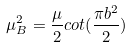Convert formula to latex. <formula><loc_0><loc_0><loc_500><loc_500>\mu _ { B } ^ { 2 } = \frac { \mu } { 2 } c o t ( \frac { \pi b ^ { 2 } } 2 )</formula> 